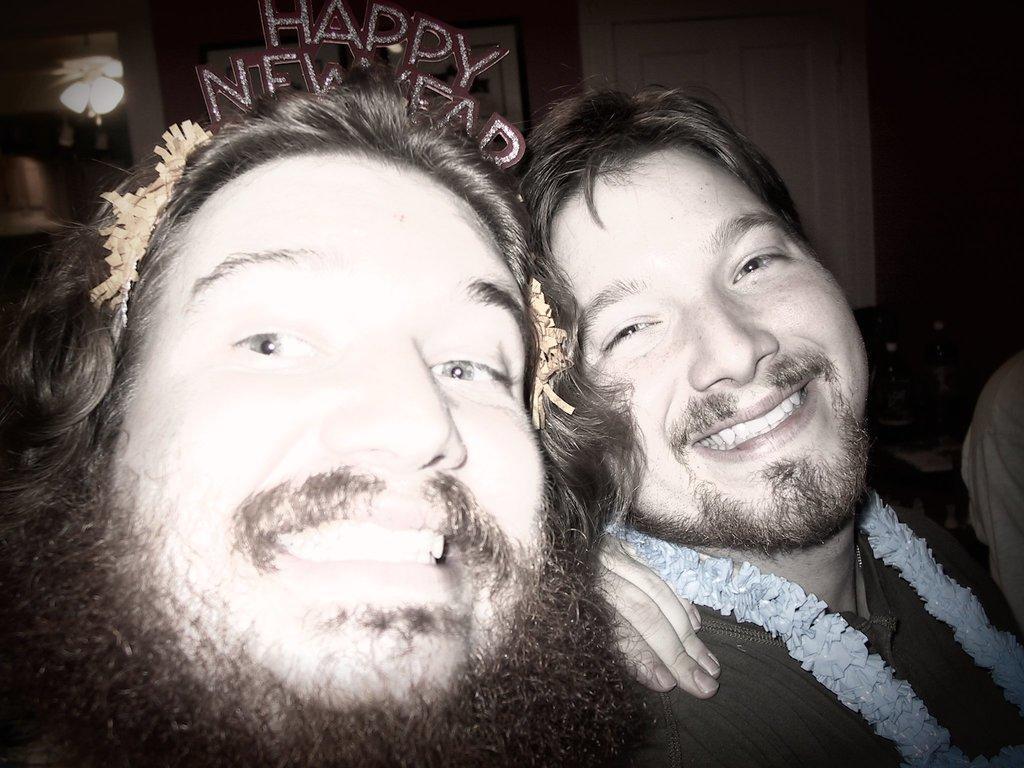Could you give a brief overview of what you see in this image? In this image we can see group of people. One person is wearing a garland in his neck. In the background we can see group of bottles ,window and photo frames. 